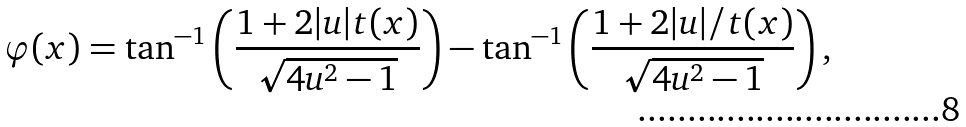Convert formula to latex. <formula><loc_0><loc_0><loc_500><loc_500>\varphi ( x ) = \tan ^ { - 1 } \left ( \frac { 1 + 2 | u | t ( x ) } { \sqrt { 4 u ^ { 2 } - 1 } } \right ) - \tan ^ { - 1 } \left ( \frac { 1 + 2 | u | / t ( x ) } { \sqrt { 4 u ^ { 2 } - 1 } } \right ) ,</formula> 